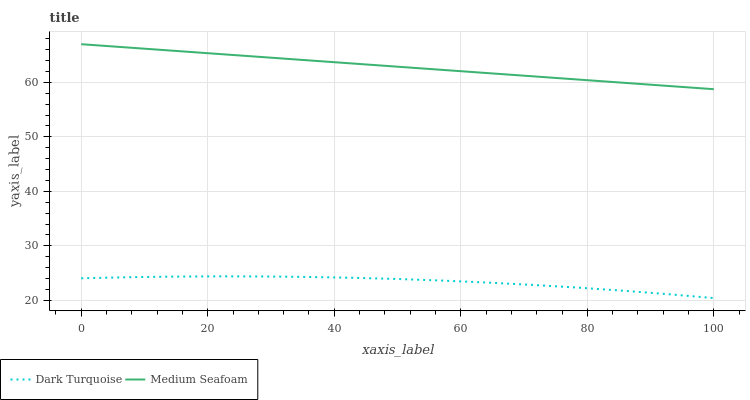Does Dark Turquoise have the minimum area under the curve?
Answer yes or no. Yes. Does Medium Seafoam have the maximum area under the curve?
Answer yes or no. Yes. Does Medium Seafoam have the minimum area under the curve?
Answer yes or no. No. Is Medium Seafoam the smoothest?
Answer yes or no. Yes. Is Dark Turquoise the roughest?
Answer yes or no. Yes. Is Medium Seafoam the roughest?
Answer yes or no. No. Does Medium Seafoam have the lowest value?
Answer yes or no. No. Is Dark Turquoise less than Medium Seafoam?
Answer yes or no. Yes. Is Medium Seafoam greater than Dark Turquoise?
Answer yes or no. Yes. Does Dark Turquoise intersect Medium Seafoam?
Answer yes or no. No. 